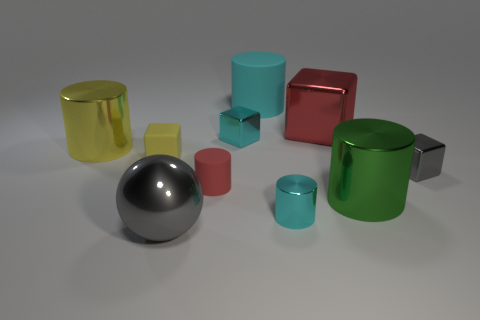Is the size of the green object the same as the yellow block?
Make the answer very short. No. What is the gray object that is behind the red cylinder made of?
Provide a short and direct response. Metal. What number of other objects are there of the same shape as the red rubber thing?
Your answer should be very brief. 4. Is the small yellow thing the same shape as the tiny gray thing?
Keep it short and to the point. Yes. There is a tiny red matte object; are there any gray shiny objects behind it?
Keep it short and to the point. Yes. How many things are either tiny purple matte things or small shiny blocks?
Make the answer very short. 2. What number of other objects are there of the same size as the gray ball?
Your response must be concise. 4. What number of large things are behind the big green object and in front of the cyan matte cylinder?
Provide a succinct answer. 2. Is the size of the gray thing in front of the green metallic thing the same as the cyan thing that is behind the large metal cube?
Provide a succinct answer. Yes. There is a green metal thing on the right side of the ball; what is its size?
Give a very brief answer. Large. 